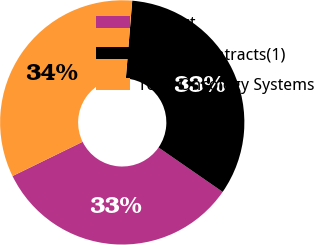<chart> <loc_0><loc_0><loc_500><loc_500><pie_chart><fcel>Product<fcel>Service Contracts(1)<fcel>Total Oncology Systems<nl><fcel>33.13%<fcel>33.33%<fcel>33.54%<nl></chart> 